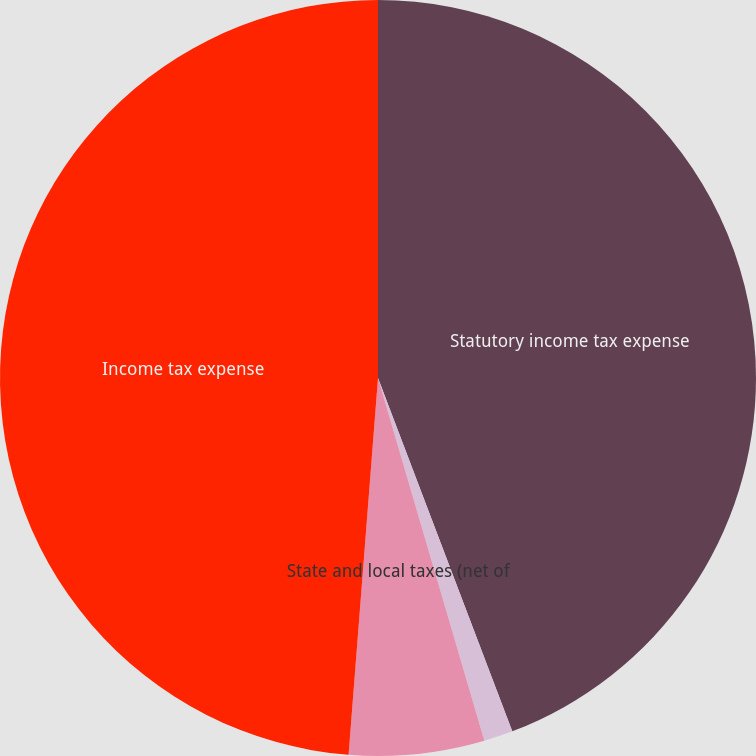Convert chart. <chart><loc_0><loc_0><loc_500><loc_500><pie_chart><fcel>Statutory income tax expense<fcel>Effect of foreign tax rates<fcel>State and local taxes (net of<fcel>Income tax expense<nl><fcel>44.22%<fcel>1.24%<fcel>5.78%<fcel>48.76%<nl></chart> 